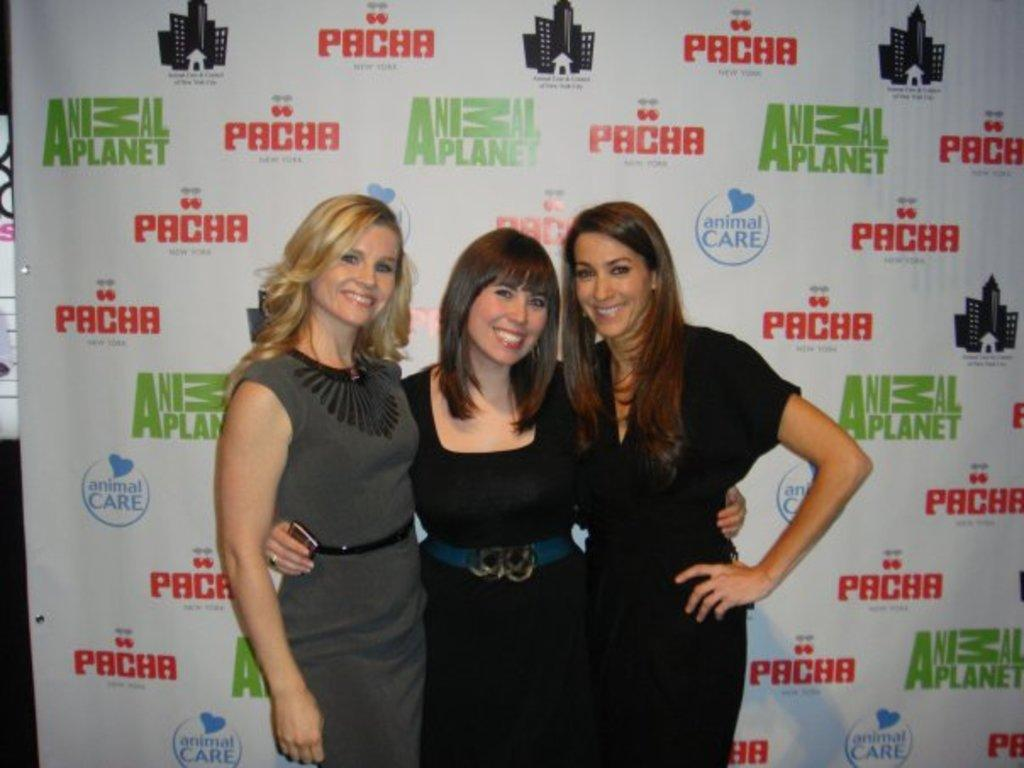How many women are in the image? There are three women in the image. What are the women doing in the image? The women are standing and smiling. What can be seen behind the women in the image? There is a banner behind the women. What type of air show can be seen in the image? There is no air show present in the image; it features three women standing and smiling with a banner behind them. Can you tell me how many carriages are visible in the image? There are no carriages present in the image. 